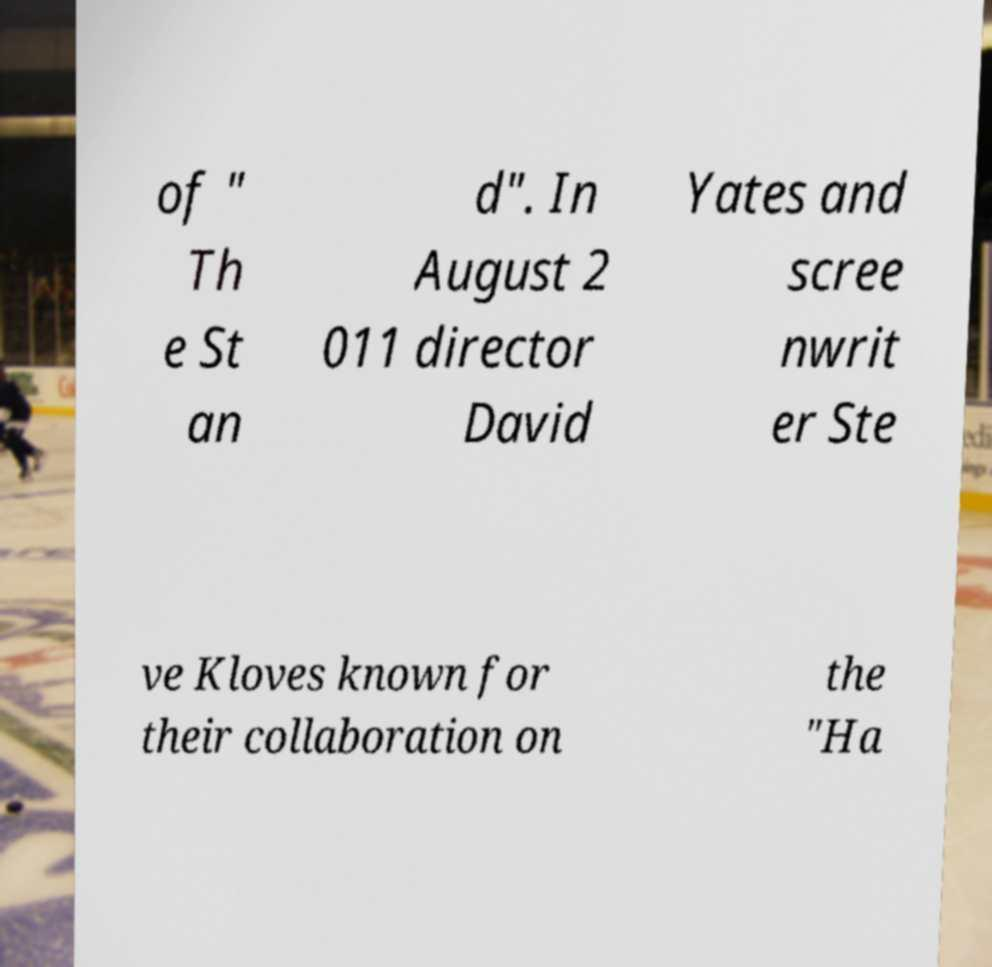Please identify and transcribe the text found in this image. of " Th e St an d". In August 2 011 director David Yates and scree nwrit er Ste ve Kloves known for their collaboration on the "Ha 